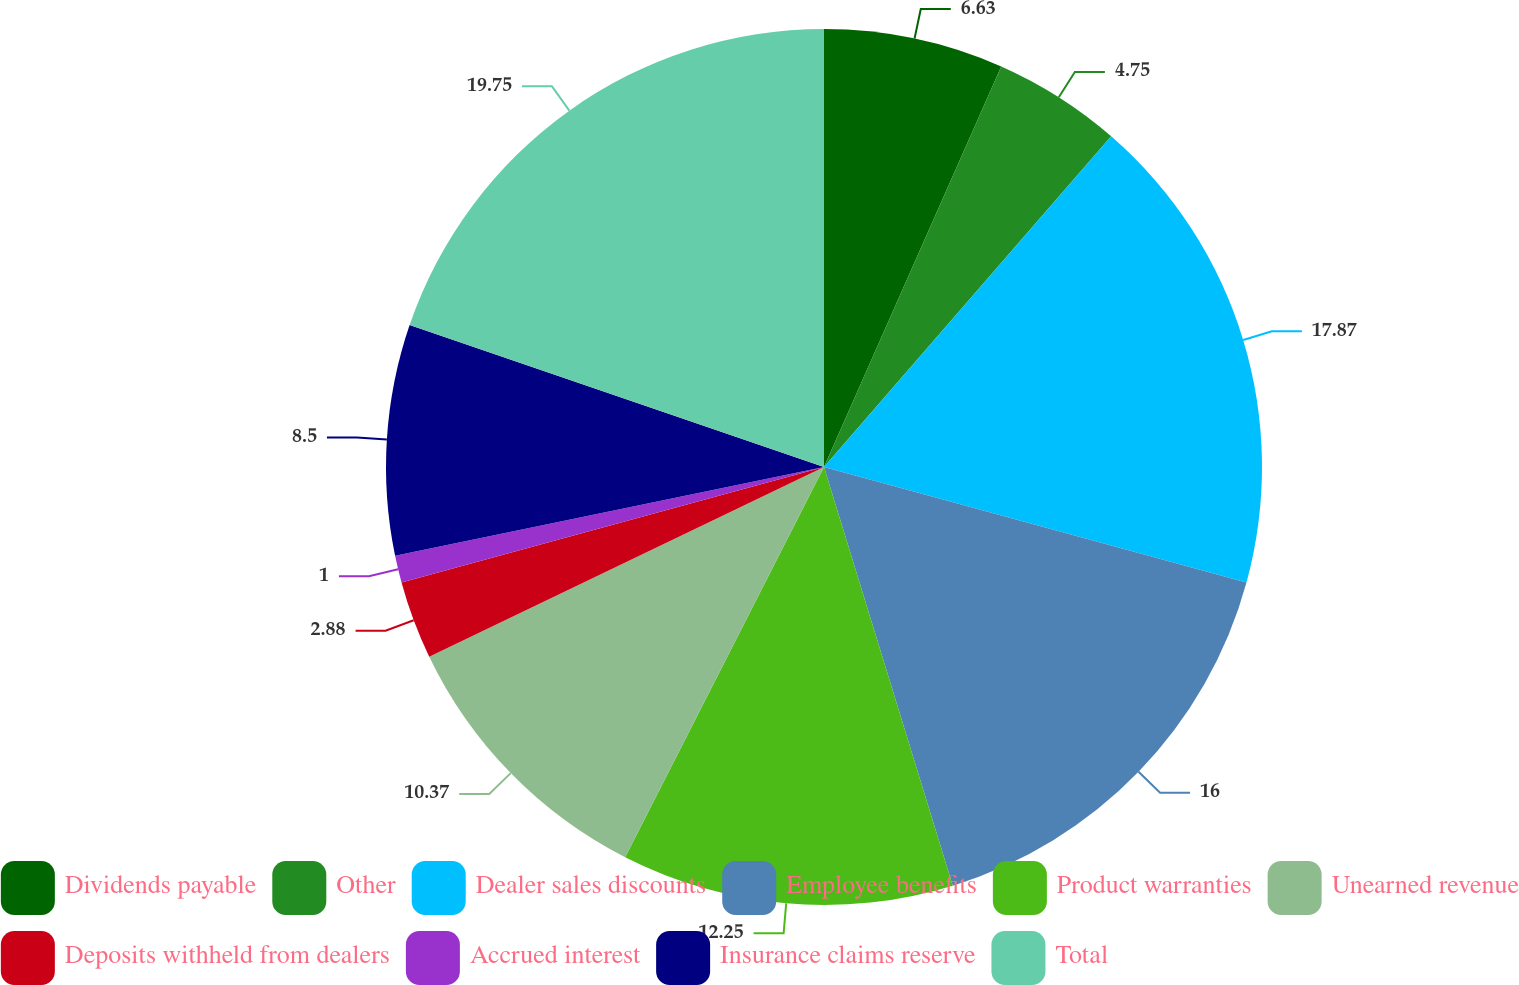Convert chart to OTSL. <chart><loc_0><loc_0><loc_500><loc_500><pie_chart><fcel>Dividends payable<fcel>Other<fcel>Dealer sales discounts<fcel>Employee benefits<fcel>Product warranties<fcel>Unearned revenue<fcel>Deposits withheld from dealers<fcel>Accrued interest<fcel>Insurance claims reserve<fcel>Total<nl><fcel>6.63%<fcel>4.75%<fcel>17.87%<fcel>16.0%<fcel>12.25%<fcel>10.37%<fcel>2.88%<fcel>1.0%<fcel>8.5%<fcel>19.75%<nl></chart> 